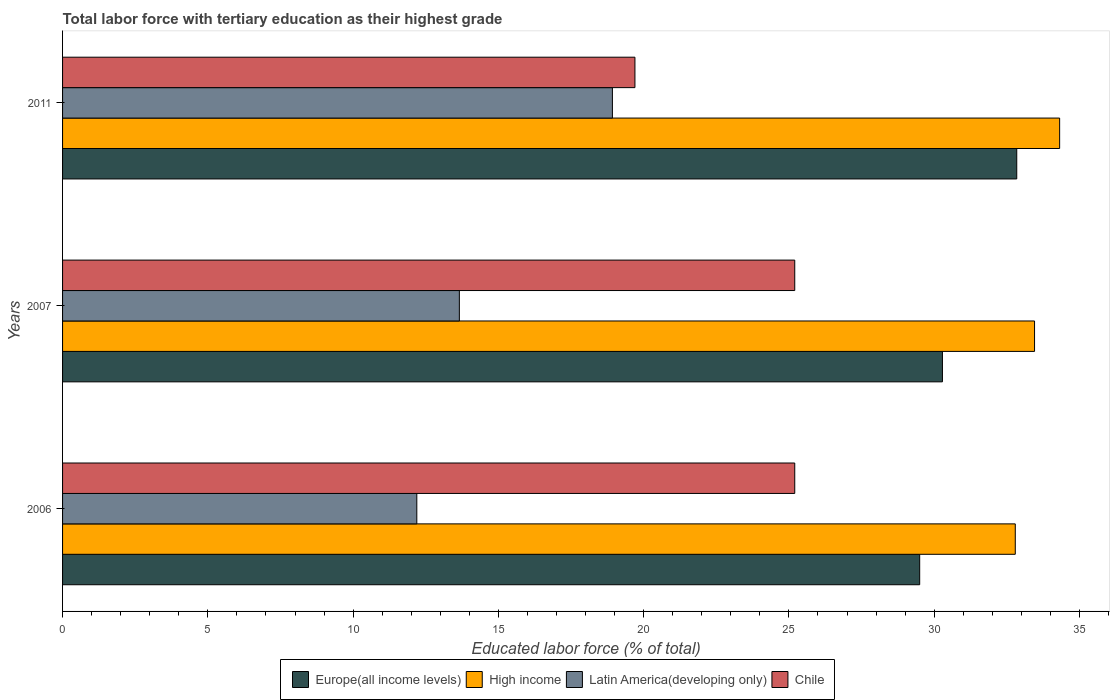How many groups of bars are there?
Ensure brevity in your answer.  3. Are the number of bars on each tick of the Y-axis equal?
Offer a terse response. Yes. How many bars are there on the 3rd tick from the top?
Your answer should be very brief. 4. How many bars are there on the 1st tick from the bottom?
Your answer should be compact. 4. What is the label of the 1st group of bars from the top?
Provide a succinct answer. 2011. In how many cases, is the number of bars for a given year not equal to the number of legend labels?
Make the answer very short. 0. What is the percentage of male labor force with tertiary education in Europe(all income levels) in 2007?
Provide a short and direct response. 30.28. Across all years, what is the maximum percentage of male labor force with tertiary education in Latin America(developing only)?
Offer a terse response. 18.92. Across all years, what is the minimum percentage of male labor force with tertiary education in Chile?
Make the answer very short. 19.7. In which year was the percentage of male labor force with tertiary education in High income minimum?
Your response must be concise. 2006. What is the total percentage of male labor force with tertiary education in Chile in the graph?
Offer a very short reply. 70.1. What is the difference between the percentage of male labor force with tertiary education in High income in 2006 and that in 2007?
Give a very brief answer. -0.66. What is the difference between the percentage of male labor force with tertiary education in Chile in 2011 and the percentage of male labor force with tertiary education in Latin America(developing only) in 2007?
Ensure brevity in your answer.  6.04. What is the average percentage of male labor force with tertiary education in Chile per year?
Make the answer very short. 23.37. In the year 2011, what is the difference between the percentage of male labor force with tertiary education in Latin America(developing only) and percentage of male labor force with tertiary education in High income?
Provide a succinct answer. -15.39. What is the ratio of the percentage of male labor force with tertiary education in Europe(all income levels) in 2006 to that in 2011?
Make the answer very short. 0.9. Is the percentage of male labor force with tertiary education in Latin America(developing only) in 2006 less than that in 2007?
Your answer should be compact. Yes. Is the difference between the percentage of male labor force with tertiary education in Latin America(developing only) in 2006 and 2007 greater than the difference between the percentage of male labor force with tertiary education in High income in 2006 and 2007?
Ensure brevity in your answer.  No. What is the difference between the highest and the second highest percentage of male labor force with tertiary education in Europe(all income levels)?
Make the answer very short. 2.56. What is the difference between the highest and the lowest percentage of male labor force with tertiary education in High income?
Offer a terse response. 1.53. Is the sum of the percentage of male labor force with tertiary education in Latin America(developing only) in 2007 and 2011 greater than the maximum percentage of male labor force with tertiary education in High income across all years?
Ensure brevity in your answer.  No. Is it the case that in every year, the sum of the percentage of male labor force with tertiary education in Latin America(developing only) and percentage of male labor force with tertiary education in Europe(all income levels) is greater than the sum of percentage of male labor force with tertiary education in High income and percentage of male labor force with tertiary education in Chile?
Provide a succinct answer. No. What does the 4th bar from the top in 2007 represents?
Your answer should be very brief. Europe(all income levels). How many bars are there?
Offer a very short reply. 12. Are all the bars in the graph horizontal?
Provide a short and direct response. Yes. Does the graph contain any zero values?
Your answer should be compact. No. Where does the legend appear in the graph?
Give a very brief answer. Bottom center. How many legend labels are there?
Keep it short and to the point. 4. What is the title of the graph?
Your answer should be very brief. Total labor force with tertiary education as their highest grade. Does "Palau" appear as one of the legend labels in the graph?
Keep it short and to the point. No. What is the label or title of the X-axis?
Make the answer very short. Educated labor force (% of total). What is the Educated labor force (% of total) in Europe(all income levels) in 2006?
Your answer should be very brief. 29.5. What is the Educated labor force (% of total) in High income in 2006?
Ensure brevity in your answer.  32.79. What is the Educated labor force (% of total) of Latin America(developing only) in 2006?
Your answer should be compact. 12.19. What is the Educated labor force (% of total) of Chile in 2006?
Provide a succinct answer. 25.2. What is the Educated labor force (% of total) in Europe(all income levels) in 2007?
Ensure brevity in your answer.  30.28. What is the Educated labor force (% of total) in High income in 2007?
Your answer should be very brief. 33.45. What is the Educated labor force (% of total) in Latin America(developing only) in 2007?
Keep it short and to the point. 13.66. What is the Educated labor force (% of total) of Chile in 2007?
Your answer should be compact. 25.2. What is the Educated labor force (% of total) of Europe(all income levels) in 2011?
Ensure brevity in your answer.  32.84. What is the Educated labor force (% of total) in High income in 2011?
Keep it short and to the point. 34.32. What is the Educated labor force (% of total) of Latin America(developing only) in 2011?
Make the answer very short. 18.92. What is the Educated labor force (% of total) in Chile in 2011?
Give a very brief answer. 19.7. Across all years, what is the maximum Educated labor force (% of total) in Europe(all income levels)?
Your response must be concise. 32.84. Across all years, what is the maximum Educated labor force (% of total) in High income?
Provide a succinct answer. 34.32. Across all years, what is the maximum Educated labor force (% of total) of Latin America(developing only)?
Provide a succinct answer. 18.92. Across all years, what is the maximum Educated labor force (% of total) of Chile?
Your answer should be very brief. 25.2. Across all years, what is the minimum Educated labor force (% of total) of Europe(all income levels)?
Offer a terse response. 29.5. Across all years, what is the minimum Educated labor force (% of total) in High income?
Offer a terse response. 32.79. Across all years, what is the minimum Educated labor force (% of total) of Latin America(developing only)?
Keep it short and to the point. 12.19. Across all years, what is the minimum Educated labor force (% of total) of Chile?
Ensure brevity in your answer.  19.7. What is the total Educated labor force (% of total) in Europe(all income levels) in the graph?
Keep it short and to the point. 92.62. What is the total Educated labor force (% of total) in High income in the graph?
Your response must be concise. 100.56. What is the total Educated labor force (% of total) of Latin America(developing only) in the graph?
Offer a terse response. 44.77. What is the total Educated labor force (% of total) of Chile in the graph?
Offer a very short reply. 70.1. What is the difference between the Educated labor force (% of total) in Europe(all income levels) in 2006 and that in 2007?
Offer a very short reply. -0.78. What is the difference between the Educated labor force (% of total) of High income in 2006 and that in 2007?
Ensure brevity in your answer.  -0.66. What is the difference between the Educated labor force (% of total) in Latin America(developing only) in 2006 and that in 2007?
Make the answer very short. -1.46. What is the difference between the Educated labor force (% of total) in Chile in 2006 and that in 2007?
Your answer should be compact. 0. What is the difference between the Educated labor force (% of total) of Europe(all income levels) in 2006 and that in 2011?
Your response must be concise. -3.34. What is the difference between the Educated labor force (% of total) of High income in 2006 and that in 2011?
Your answer should be compact. -1.53. What is the difference between the Educated labor force (% of total) in Latin America(developing only) in 2006 and that in 2011?
Your answer should be very brief. -6.73. What is the difference between the Educated labor force (% of total) in Chile in 2006 and that in 2011?
Your answer should be compact. 5.5. What is the difference between the Educated labor force (% of total) of Europe(all income levels) in 2007 and that in 2011?
Ensure brevity in your answer.  -2.56. What is the difference between the Educated labor force (% of total) of High income in 2007 and that in 2011?
Provide a short and direct response. -0.86. What is the difference between the Educated labor force (% of total) in Latin America(developing only) in 2007 and that in 2011?
Offer a very short reply. -5.27. What is the difference between the Educated labor force (% of total) of Chile in 2007 and that in 2011?
Your answer should be very brief. 5.5. What is the difference between the Educated labor force (% of total) of Europe(all income levels) in 2006 and the Educated labor force (% of total) of High income in 2007?
Your answer should be very brief. -3.95. What is the difference between the Educated labor force (% of total) in Europe(all income levels) in 2006 and the Educated labor force (% of total) in Latin America(developing only) in 2007?
Offer a very short reply. 15.84. What is the difference between the Educated labor force (% of total) of Europe(all income levels) in 2006 and the Educated labor force (% of total) of Chile in 2007?
Your answer should be compact. 4.3. What is the difference between the Educated labor force (% of total) of High income in 2006 and the Educated labor force (% of total) of Latin America(developing only) in 2007?
Provide a short and direct response. 19.13. What is the difference between the Educated labor force (% of total) in High income in 2006 and the Educated labor force (% of total) in Chile in 2007?
Provide a short and direct response. 7.59. What is the difference between the Educated labor force (% of total) in Latin America(developing only) in 2006 and the Educated labor force (% of total) in Chile in 2007?
Keep it short and to the point. -13.01. What is the difference between the Educated labor force (% of total) of Europe(all income levels) in 2006 and the Educated labor force (% of total) of High income in 2011?
Keep it short and to the point. -4.82. What is the difference between the Educated labor force (% of total) in Europe(all income levels) in 2006 and the Educated labor force (% of total) in Latin America(developing only) in 2011?
Your answer should be compact. 10.58. What is the difference between the Educated labor force (% of total) in Europe(all income levels) in 2006 and the Educated labor force (% of total) in Chile in 2011?
Your response must be concise. 9.8. What is the difference between the Educated labor force (% of total) of High income in 2006 and the Educated labor force (% of total) of Latin America(developing only) in 2011?
Your response must be concise. 13.87. What is the difference between the Educated labor force (% of total) in High income in 2006 and the Educated labor force (% of total) in Chile in 2011?
Provide a succinct answer. 13.09. What is the difference between the Educated labor force (% of total) in Latin America(developing only) in 2006 and the Educated labor force (% of total) in Chile in 2011?
Keep it short and to the point. -7.51. What is the difference between the Educated labor force (% of total) of Europe(all income levels) in 2007 and the Educated labor force (% of total) of High income in 2011?
Provide a succinct answer. -4.03. What is the difference between the Educated labor force (% of total) of Europe(all income levels) in 2007 and the Educated labor force (% of total) of Latin America(developing only) in 2011?
Keep it short and to the point. 11.36. What is the difference between the Educated labor force (% of total) of Europe(all income levels) in 2007 and the Educated labor force (% of total) of Chile in 2011?
Provide a short and direct response. 10.58. What is the difference between the Educated labor force (% of total) in High income in 2007 and the Educated labor force (% of total) in Latin America(developing only) in 2011?
Provide a short and direct response. 14.53. What is the difference between the Educated labor force (% of total) of High income in 2007 and the Educated labor force (% of total) of Chile in 2011?
Ensure brevity in your answer.  13.75. What is the difference between the Educated labor force (% of total) in Latin America(developing only) in 2007 and the Educated labor force (% of total) in Chile in 2011?
Your answer should be compact. -6.04. What is the average Educated labor force (% of total) of Europe(all income levels) per year?
Ensure brevity in your answer.  30.87. What is the average Educated labor force (% of total) of High income per year?
Your answer should be very brief. 33.52. What is the average Educated labor force (% of total) of Latin America(developing only) per year?
Ensure brevity in your answer.  14.92. What is the average Educated labor force (% of total) in Chile per year?
Your answer should be compact. 23.37. In the year 2006, what is the difference between the Educated labor force (% of total) of Europe(all income levels) and Educated labor force (% of total) of High income?
Provide a succinct answer. -3.29. In the year 2006, what is the difference between the Educated labor force (% of total) of Europe(all income levels) and Educated labor force (% of total) of Latin America(developing only)?
Provide a short and direct response. 17.31. In the year 2006, what is the difference between the Educated labor force (% of total) in Europe(all income levels) and Educated labor force (% of total) in Chile?
Offer a terse response. 4.3. In the year 2006, what is the difference between the Educated labor force (% of total) of High income and Educated labor force (% of total) of Latin America(developing only)?
Make the answer very short. 20.6. In the year 2006, what is the difference between the Educated labor force (% of total) of High income and Educated labor force (% of total) of Chile?
Keep it short and to the point. 7.59. In the year 2006, what is the difference between the Educated labor force (% of total) in Latin America(developing only) and Educated labor force (% of total) in Chile?
Provide a succinct answer. -13.01. In the year 2007, what is the difference between the Educated labor force (% of total) in Europe(all income levels) and Educated labor force (% of total) in High income?
Offer a very short reply. -3.17. In the year 2007, what is the difference between the Educated labor force (% of total) in Europe(all income levels) and Educated labor force (% of total) in Latin America(developing only)?
Your answer should be compact. 16.63. In the year 2007, what is the difference between the Educated labor force (% of total) in Europe(all income levels) and Educated labor force (% of total) in Chile?
Your answer should be compact. 5.08. In the year 2007, what is the difference between the Educated labor force (% of total) in High income and Educated labor force (% of total) in Latin America(developing only)?
Provide a short and direct response. 19.8. In the year 2007, what is the difference between the Educated labor force (% of total) of High income and Educated labor force (% of total) of Chile?
Ensure brevity in your answer.  8.25. In the year 2007, what is the difference between the Educated labor force (% of total) in Latin America(developing only) and Educated labor force (% of total) in Chile?
Ensure brevity in your answer.  -11.54. In the year 2011, what is the difference between the Educated labor force (% of total) in Europe(all income levels) and Educated labor force (% of total) in High income?
Make the answer very short. -1.48. In the year 2011, what is the difference between the Educated labor force (% of total) of Europe(all income levels) and Educated labor force (% of total) of Latin America(developing only)?
Offer a terse response. 13.92. In the year 2011, what is the difference between the Educated labor force (% of total) of Europe(all income levels) and Educated labor force (% of total) of Chile?
Ensure brevity in your answer.  13.14. In the year 2011, what is the difference between the Educated labor force (% of total) of High income and Educated labor force (% of total) of Latin America(developing only)?
Make the answer very short. 15.39. In the year 2011, what is the difference between the Educated labor force (% of total) in High income and Educated labor force (% of total) in Chile?
Your answer should be compact. 14.62. In the year 2011, what is the difference between the Educated labor force (% of total) of Latin America(developing only) and Educated labor force (% of total) of Chile?
Provide a short and direct response. -0.78. What is the ratio of the Educated labor force (% of total) in Europe(all income levels) in 2006 to that in 2007?
Provide a short and direct response. 0.97. What is the ratio of the Educated labor force (% of total) of High income in 2006 to that in 2007?
Provide a short and direct response. 0.98. What is the ratio of the Educated labor force (% of total) of Latin America(developing only) in 2006 to that in 2007?
Provide a short and direct response. 0.89. What is the ratio of the Educated labor force (% of total) in Chile in 2006 to that in 2007?
Offer a terse response. 1. What is the ratio of the Educated labor force (% of total) of Europe(all income levels) in 2006 to that in 2011?
Provide a short and direct response. 0.9. What is the ratio of the Educated labor force (% of total) in High income in 2006 to that in 2011?
Your response must be concise. 0.96. What is the ratio of the Educated labor force (% of total) in Latin America(developing only) in 2006 to that in 2011?
Provide a short and direct response. 0.64. What is the ratio of the Educated labor force (% of total) in Chile in 2006 to that in 2011?
Your answer should be very brief. 1.28. What is the ratio of the Educated labor force (% of total) of Europe(all income levels) in 2007 to that in 2011?
Your response must be concise. 0.92. What is the ratio of the Educated labor force (% of total) of High income in 2007 to that in 2011?
Keep it short and to the point. 0.97. What is the ratio of the Educated labor force (% of total) in Latin America(developing only) in 2007 to that in 2011?
Your response must be concise. 0.72. What is the ratio of the Educated labor force (% of total) in Chile in 2007 to that in 2011?
Provide a succinct answer. 1.28. What is the difference between the highest and the second highest Educated labor force (% of total) in Europe(all income levels)?
Your response must be concise. 2.56. What is the difference between the highest and the second highest Educated labor force (% of total) in High income?
Your answer should be very brief. 0.86. What is the difference between the highest and the second highest Educated labor force (% of total) of Latin America(developing only)?
Keep it short and to the point. 5.27. What is the difference between the highest and the lowest Educated labor force (% of total) in Europe(all income levels)?
Keep it short and to the point. 3.34. What is the difference between the highest and the lowest Educated labor force (% of total) of High income?
Provide a short and direct response. 1.53. What is the difference between the highest and the lowest Educated labor force (% of total) of Latin America(developing only)?
Provide a succinct answer. 6.73. 